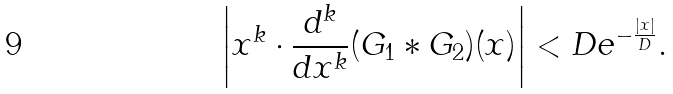Convert formula to latex. <formula><loc_0><loc_0><loc_500><loc_500>\left | x ^ { k } \cdot \frac { d ^ { k } } { d x ^ { k } } ( G _ { 1 } \ast G _ { 2 } ) ( x ) \right | < D e ^ { - \frac { | x | } { D } } .</formula> 